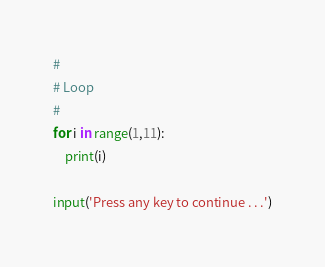Convert code to text. <code><loc_0><loc_0><loc_500><loc_500><_Python_>#
# Loop
#
for i in range(1,11):
    print(i)

input('Press any key to continue . . .')
</code> 